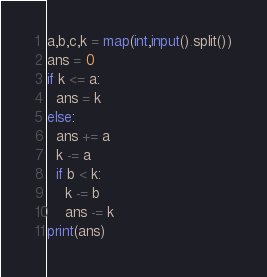Convert code to text. <code><loc_0><loc_0><loc_500><loc_500><_Python_>a,b,c,k = map(int,input().split())
ans = 0
if k <= a:
  ans = k
else:
  ans += a
  k -= a
  if b < k:
    k -= b
    ans -= k
print(ans)</code> 